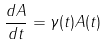<formula> <loc_0><loc_0><loc_500><loc_500>\frac { d A } { d t } = \gamma ( t ) A ( t )</formula> 